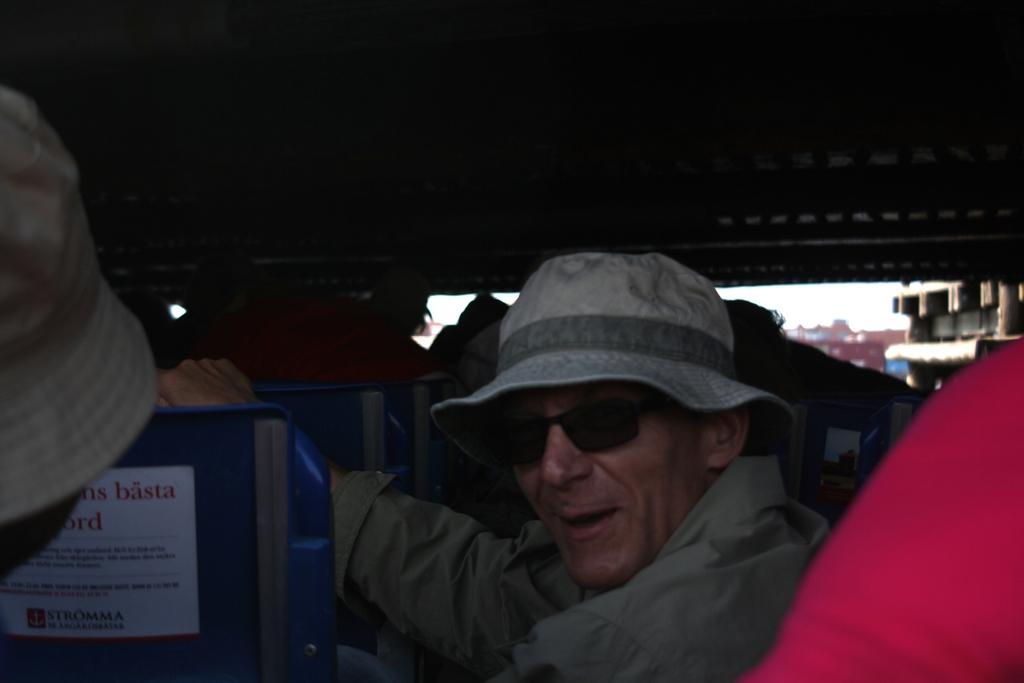Could you give a brief overview of what you see in this image? This is an inside view of a vehicle. In which we can see a group of people sitting on the chairs. We can also see a paper with some text on it pasted on a chair. On the backside we can see some buildings and the sky. 